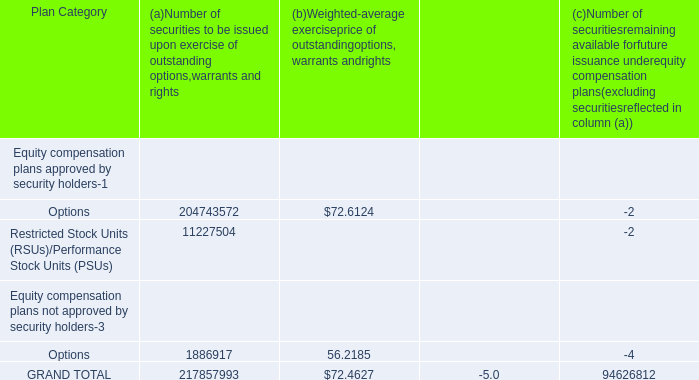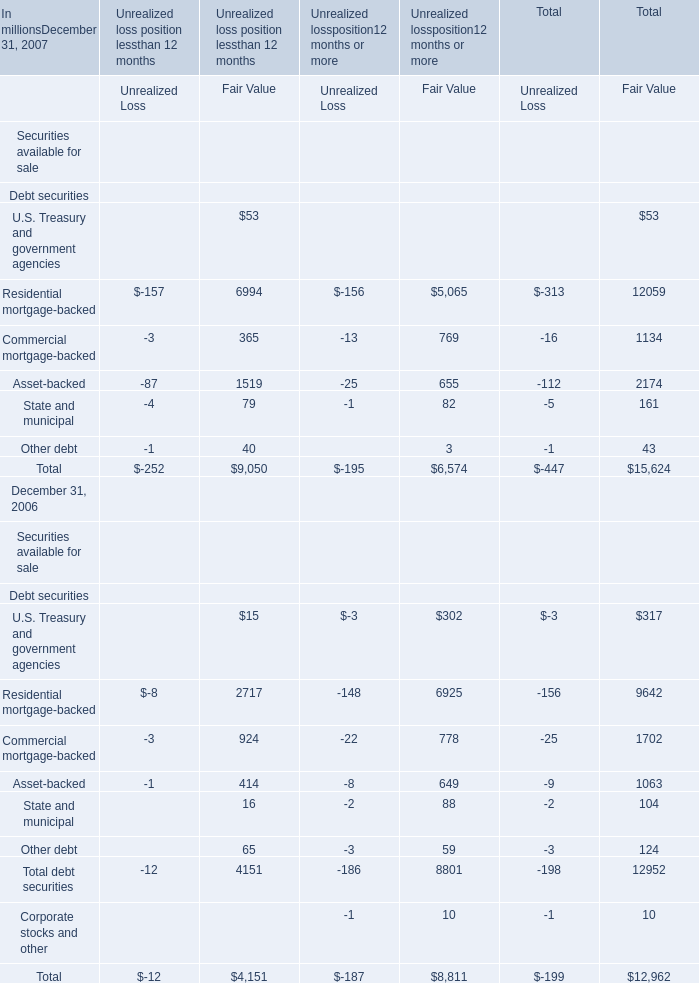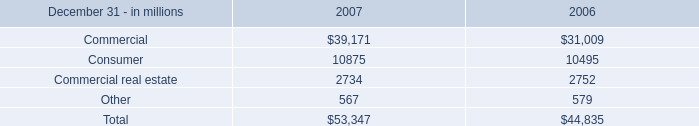What was the Fair Value for Total debt securities in terms of Unrealized loss position 12 months or more at December 31, 2006? (in million) 
Answer: 8801. 